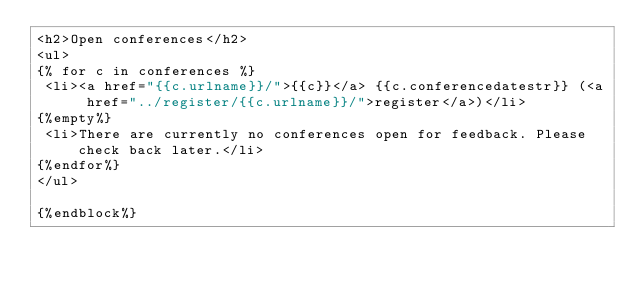<code> <loc_0><loc_0><loc_500><loc_500><_HTML_><h2>Open conferences</h2>
<ul>
{% for c in conferences %}
 <li><a href="{{c.urlname}}/">{{c}}</a> {{c.conferencedatestr}} (<a href="../register/{{c.urlname}}/">register</a>)</li>
{%empty%}
 <li>There are currently no conferences open for feedback. Please check back later.</li>
{%endfor%}
</ul>

{%endblock%}
</code> 